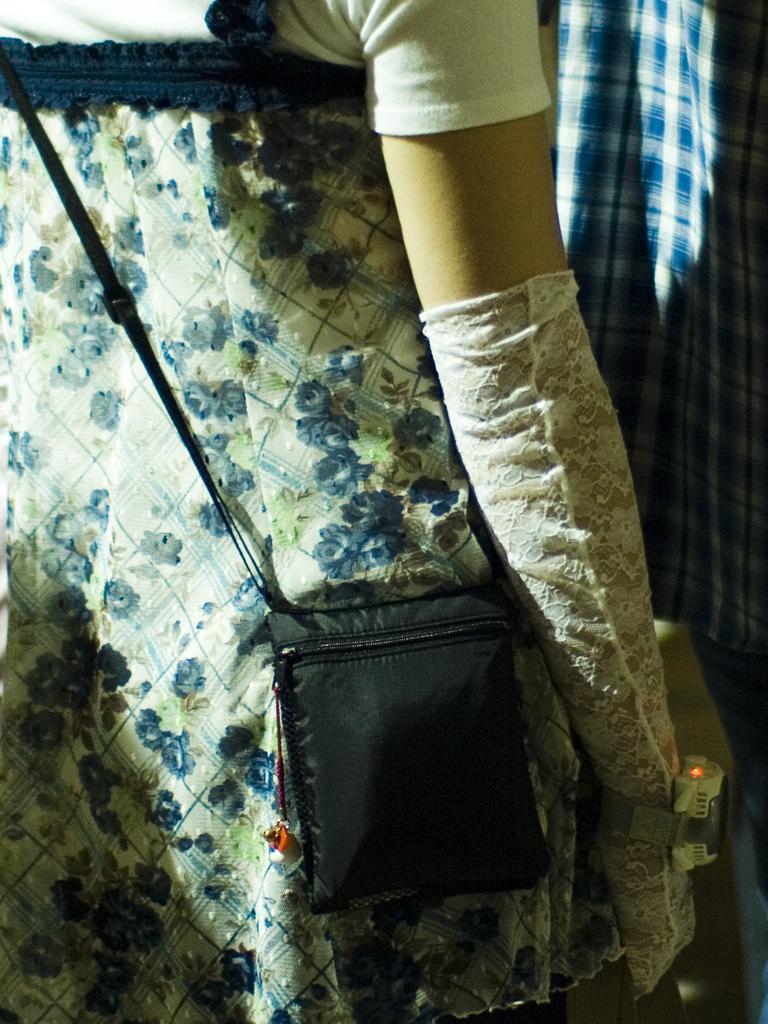Could you give a brief overview of what you see in this image? This is a zoomed in picture. In the foreground there is a person wearing a white color dress, black color sling bag, glove and seems to be standing on the ground. In the background there is a blue color cloth. 